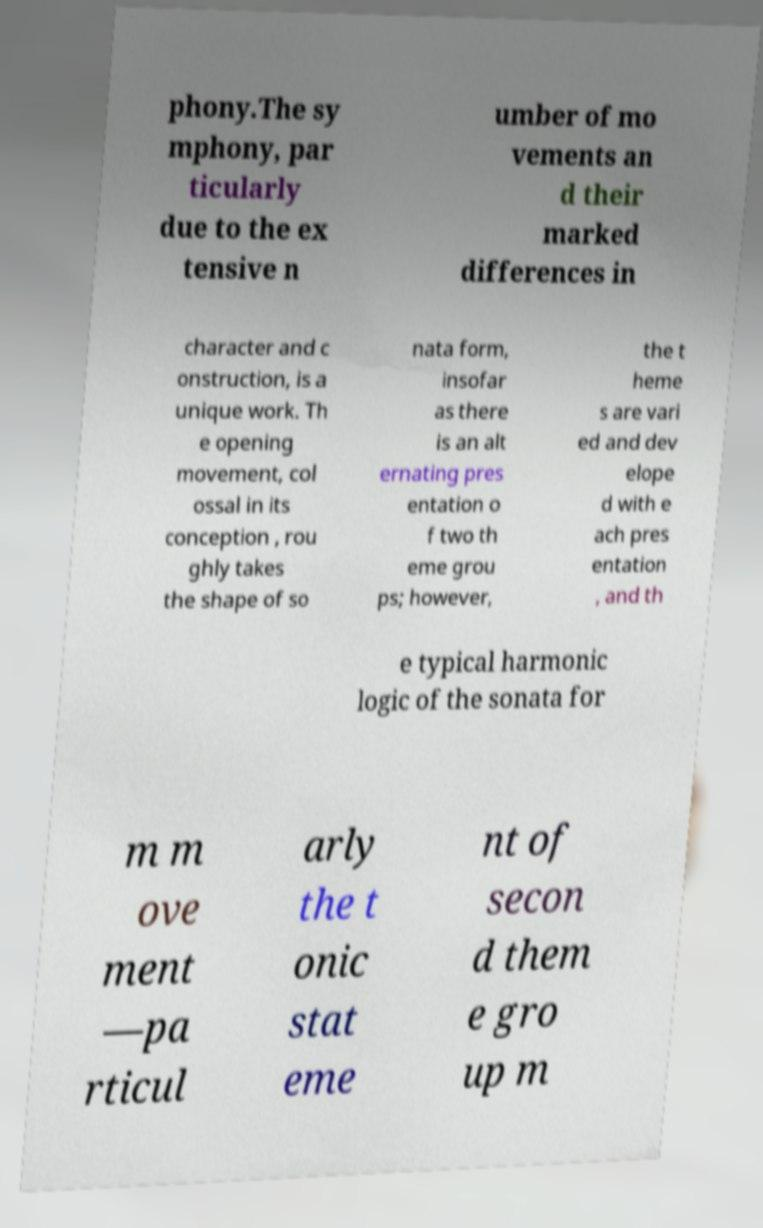Can you read and provide the text displayed in the image?This photo seems to have some interesting text. Can you extract and type it out for me? phony.The sy mphony, par ticularly due to the ex tensive n umber of mo vements an d their marked differences in character and c onstruction, is a unique work. Th e opening movement, col ossal in its conception , rou ghly takes the shape of so nata form, insofar as there is an alt ernating pres entation o f two th eme grou ps; however, the t heme s are vari ed and dev elope d with e ach pres entation , and th e typical harmonic logic of the sonata for m m ove ment —pa rticul arly the t onic stat eme nt of secon d them e gro up m 